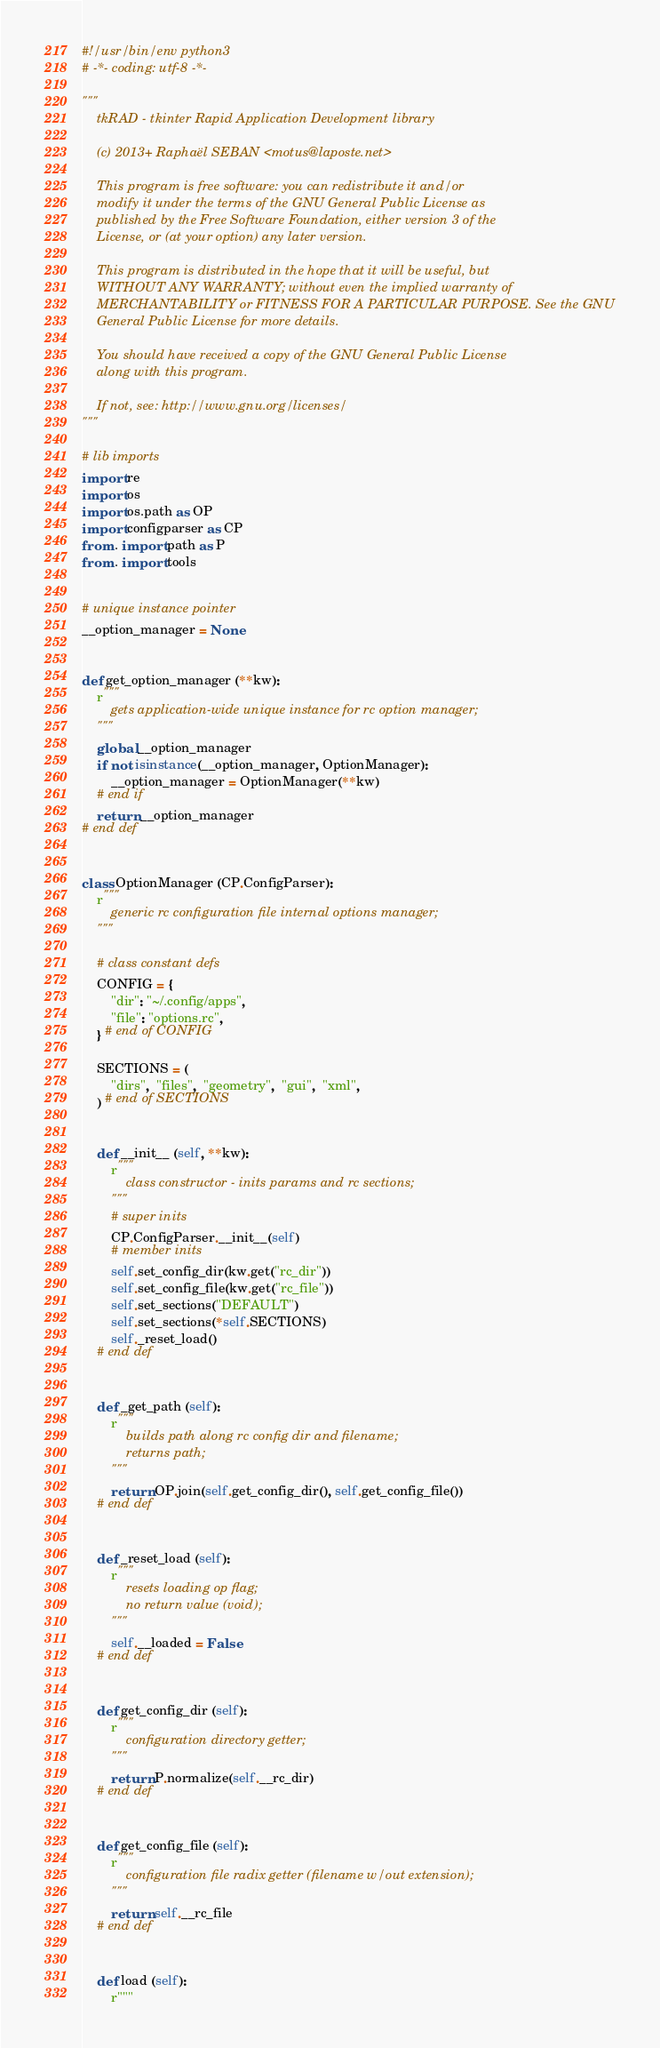Convert code to text. <code><loc_0><loc_0><loc_500><loc_500><_Python_>#!/usr/bin/env python3
# -*- coding: utf-8 -*-

"""
    tkRAD - tkinter Rapid Application Development library

    (c) 2013+ Raphaël SEBAN <motus@laposte.net>

    This program is free software: you can redistribute it and/or
    modify it under the terms of the GNU General Public License as
    published by the Free Software Foundation, either version 3 of the
    License, or (at your option) any later version.

    This program is distributed in the hope that it will be useful, but
    WITHOUT ANY WARRANTY; without even the implied warranty of
    MERCHANTABILITY or FITNESS FOR A PARTICULAR PURPOSE. See the GNU
    General Public License for more details.

    You should have received a copy of the GNU General Public License
    along with this program.

    If not, see: http://www.gnu.org/licenses/
"""

# lib imports
import re
import os
import os.path as OP
import configparser as CP
from . import path as P
from . import tools


# unique instance pointer
__option_manager = None


def get_option_manager (**kw):
    r"""
        gets application-wide unique instance for rc option manager;
    """
    global __option_manager
    if not isinstance(__option_manager, OptionManager):
        __option_manager = OptionManager(**kw)
    # end if
    return __option_manager
# end def


class OptionManager (CP.ConfigParser):
    r"""
        generic rc configuration file internal options manager;
    """

    # class constant defs
    CONFIG = {
        "dir": "~/.config/apps",
        "file": "options.rc",
    } # end of CONFIG

    SECTIONS = (
        "dirs",  "files",  "geometry",  "gui",  "xml",
    ) # end of SECTIONS


    def __init__ (self, **kw):
        r"""
            class constructor - inits params and rc sections;
        """
        # super inits
        CP.ConfigParser.__init__(self)
        # member inits
        self.set_config_dir(kw.get("rc_dir"))
        self.set_config_file(kw.get("rc_file"))
        self.set_sections("DEFAULT")
        self.set_sections(*self.SECTIONS)
        self._reset_load()
    # end def


    def _get_path (self):
        r"""
            builds path along rc config dir and filename;
            returns path;
        """
        return OP.join(self.get_config_dir(), self.get_config_file())
    # end def


    def _reset_load (self):
        r"""
            resets loading op flag;
            no return value (void);
        """
        self.__loaded = False
    # end def


    def get_config_dir (self):
        r"""
            configuration directory getter;
        """
        return P.normalize(self.__rc_dir)
    # end def


    def get_config_file (self):
        r"""
            configuration file radix getter (filename w/out extension);
        """
        return self.__rc_file
    # end def


    def load (self):
        r"""</code> 